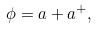<formula> <loc_0><loc_0><loc_500><loc_500>\phi = a + a ^ { + } ,</formula> 